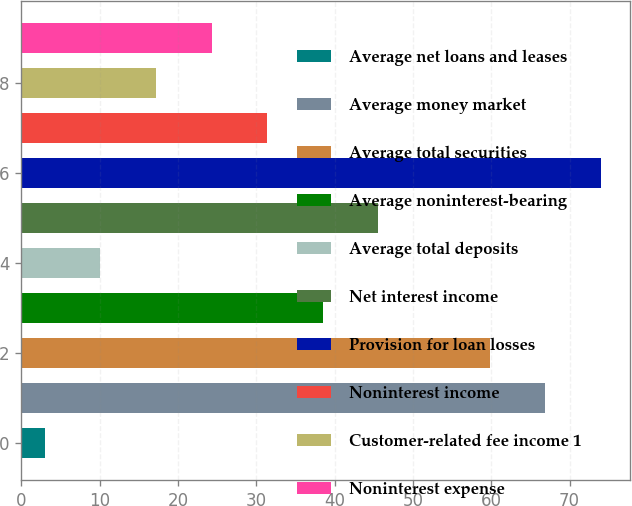Convert chart. <chart><loc_0><loc_0><loc_500><loc_500><bar_chart><fcel>Average net loans and leases<fcel>Average money market<fcel>Average total securities<fcel>Average noninterest-bearing<fcel>Average total deposits<fcel>Net interest income<fcel>Provision for loan losses<fcel>Noninterest income<fcel>Customer-related fee income 1<fcel>Noninterest expense<nl><fcel>3<fcel>66.9<fcel>59.8<fcel>38.5<fcel>10.1<fcel>45.6<fcel>74<fcel>31.4<fcel>17.2<fcel>24.3<nl></chart> 